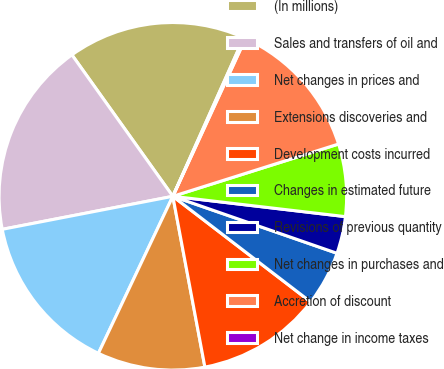Convert chart to OTSL. <chart><loc_0><loc_0><loc_500><loc_500><pie_chart><fcel>(In millions)<fcel>Sales and transfers of oil and<fcel>Net changes in prices and<fcel>Extensions discoveries and<fcel>Development costs incurred<fcel>Changes in estimated future<fcel>Revisions of previous quantity<fcel>Net changes in purchases and<fcel>Accretion of discount<fcel>Net change in income taxes<nl><fcel>16.55%<fcel>18.18%<fcel>14.91%<fcel>10.0%<fcel>11.64%<fcel>5.09%<fcel>3.45%<fcel>6.73%<fcel>13.27%<fcel>0.18%<nl></chart> 